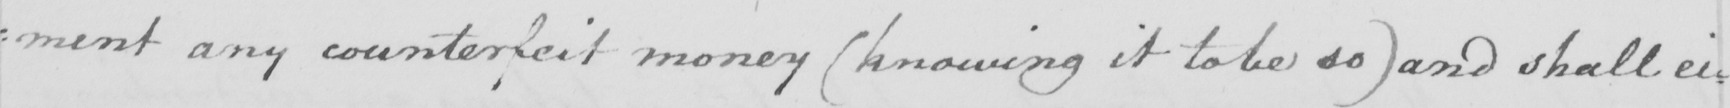What is written in this line of handwriting? : ment any counterfeit money  ( knowing it to be so )  and shall ei= 